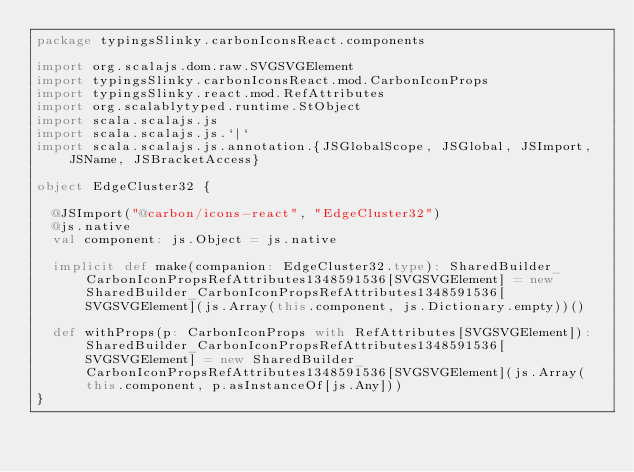Convert code to text. <code><loc_0><loc_0><loc_500><loc_500><_Scala_>package typingsSlinky.carbonIconsReact.components

import org.scalajs.dom.raw.SVGSVGElement
import typingsSlinky.carbonIconsReact.mod.CarbonIconProps
import typingsSlinky.react.mod.RefAttributes
import org.scalablytyped.runtime.StObject
import scala.scalajs.js
import scala.scalajs.js.`|`
import scala.scalajs.js.annotation.{JSGlobalScope, JSGlobal, JSImport, JSName, JSBracketAccess}

object EdgeCluster32 {
  
  @JSImport("@carbon/icons-react", "EdgeCluster32")
  @js.native
  val component: js.Object = js.native
  
  implicit def make(companion: EdgeCluster32.type): SharedBuilder_CarbonIconPropsRefAttributes1348591536[SVGSVGElement] = new SharedBuilder_CarbonIconPropsRefAttributes1348591536[SVGSVGElement](js.Array(this.component, js.Dictionary.empty))()
  
  def withProps(p: CarbonIconProps with RefAttributes[SVGSVGElement]): SharedBuilder_CarbonIconPropsRefAttributes1348591536[SVGSVGElement] = new SharedBuilder_CarbonIconPropsRefAttributes1348591536[SVGSVGElement](js.Array(this.component, p.asInstanceOf[js.Any]))
}
</code> 